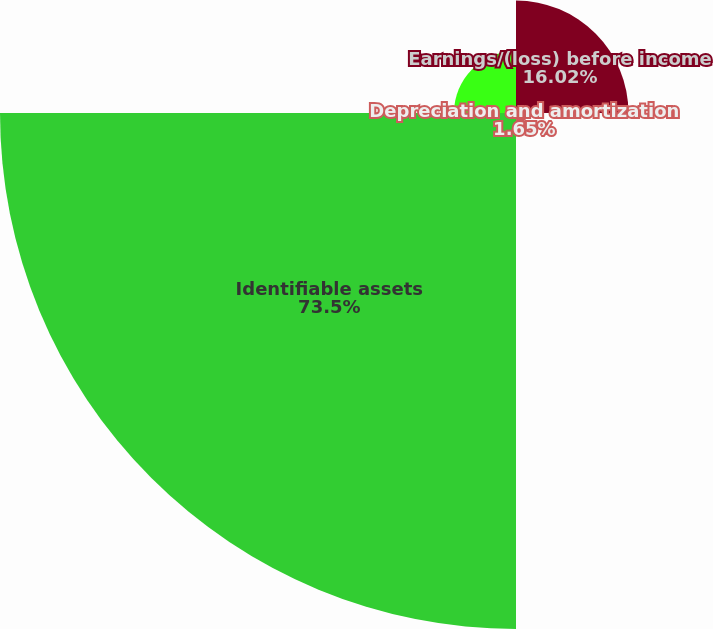Convert chart to OTSL. <chart><loc_0><loc_0><loc_500><loc_500><pie_chart><fcel>Earnings/(loss) before income<fcel>Depreciation and amortization<fcel>Identifiable assets<fcel>Net capital expenditures<nl><fcel>16.02%<fcel>1.65%<fcel>73.5%<fcel>8.83%<nl></chart> 